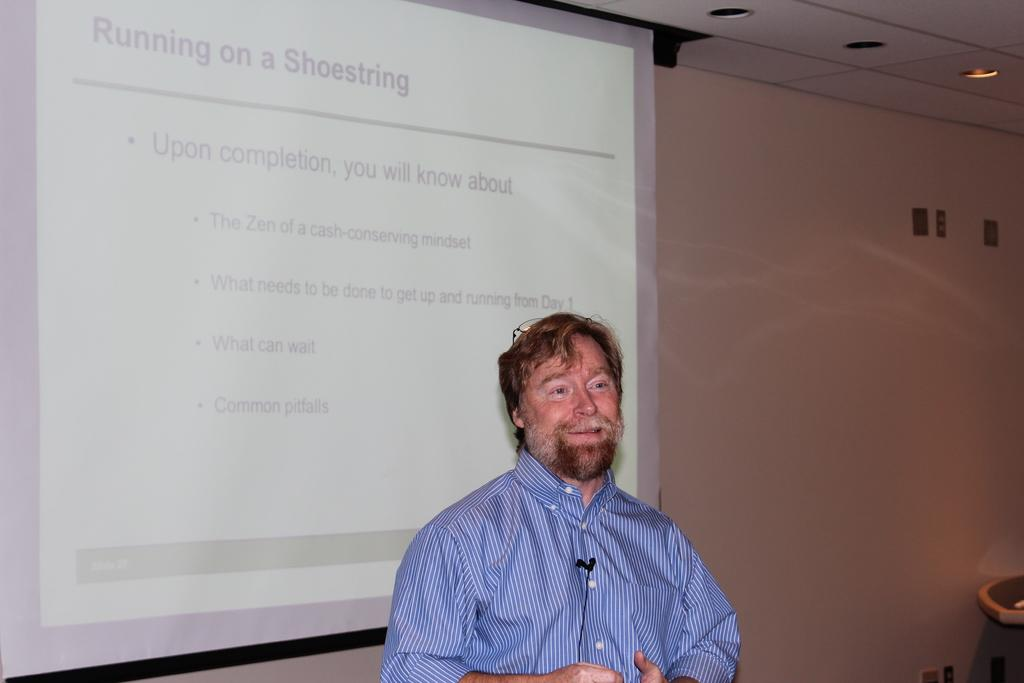What is the main subject of the image? There is a man standing in the middle of the image. What is located behind the man? There is a screen behind the man. What is behind the screen? There is a wall behind the screen. What type of riddle is the man solving on the screen? There is no riddle present on the screen in the image. How does the man's wealth affect the appearance of the wall behind the screen? The image does not provide any information about the man's wealth, so we cannot determine how it might affect the appearance of the wall. 